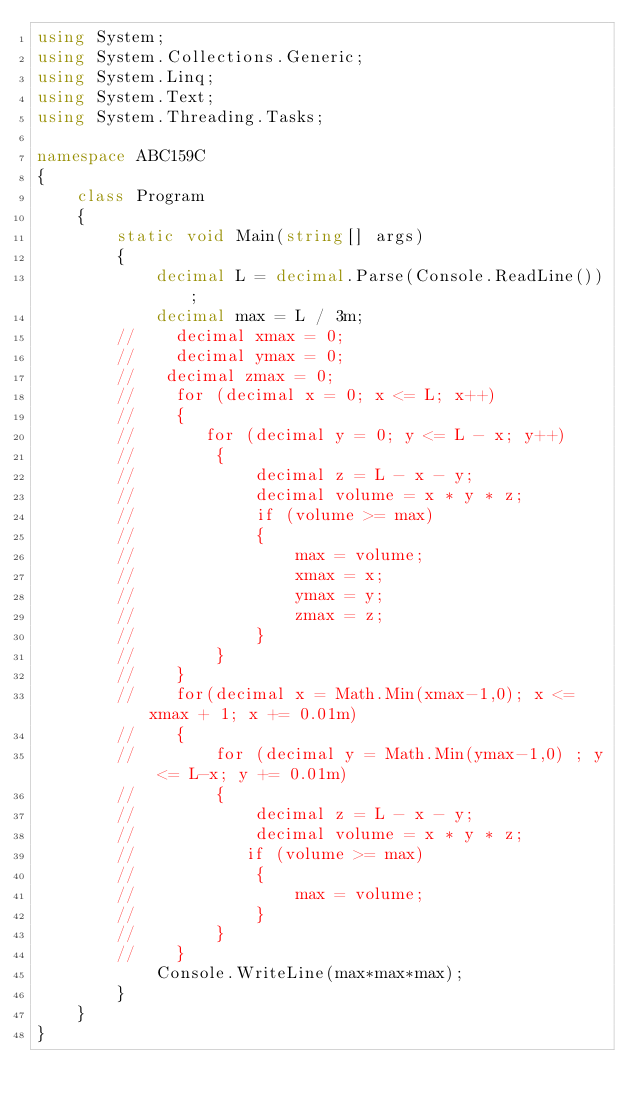<code> <loc_0><loc_0><loc_500><loc_500><_C#_>using System;
using System.Collections.Generic;
using System.Linq;
using System.Text;
using System.Threading.Tasks;

namespace ABC159C
{
    class Program
    {
        static void Main(string[] args)
        {
            decimal L = decimal.Parse(Console.ReadLine());
            decimal max = L / 3m;
        //    decimal xmax = 0;
        //    decimal ymax = 0;
        //   decimal zmax = 0;
        //    for (decimal x = 0; x <= L; x++)
        //    {
        //       for (decimal y = 0; y <= L - x; y++)
        //        {
        //            decimal z = L - x - y;
        //            decimal volume = x * y * z;
        //            if (volume >= max)
        //            {
        //                max = volume;
        //                xmax = x;
        //                ymax = y;
        //                zmax = z;
        //            }
        //        }
        //    }
        //    for(decimal x = Math.Min(xmax-1,0); x <= xmax + 1; x += 0.01m)
        //    {
        //        for (decimal y = Math.Min(ymax-1,0) ; y <= L-x; y += 0.01m)
        //        {
        //            decimal z = L - x - y;
        //            decimal volume = x * y * z;
        //           if (volume >= max)
        //            {
        //                max = volume;
        //            }
        //        }
        //    }
            Console.WriteLine(max*max*max);
        }
    }
}
</code> 